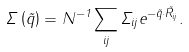Convert formula to latex. <formula><loc_0><loc_0><loc_500><loc_500>\Sigma \left ( \vec { q } \right ) = N ^ { - 1 } \sum _ { i j } \Sigma _ { i j } e ^ { - \vec { q } \cdot \vec { R } _ { i j } } .</formula> 